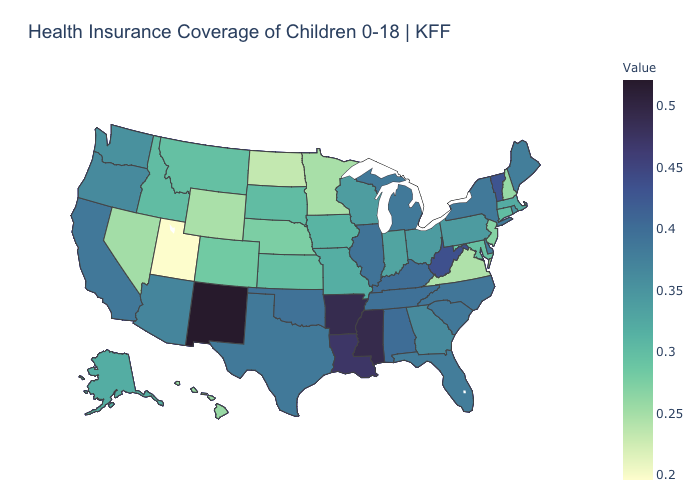Among the states that border North Dakota , which have the highest value?
Short answer required. South Dakota. Does New Mexico have the highest value in the USA?
Short answer required. Yes. Does Virginia have a lower value than Utah?
Write a very short answer. No. Does the map have missing data?
Keep it brief. No. Which states have the lowest value in the Northeast?
Give a very brief answer. New Hampshire. Is the legend a continuous bar?
Give a very brief answer. Yes. 